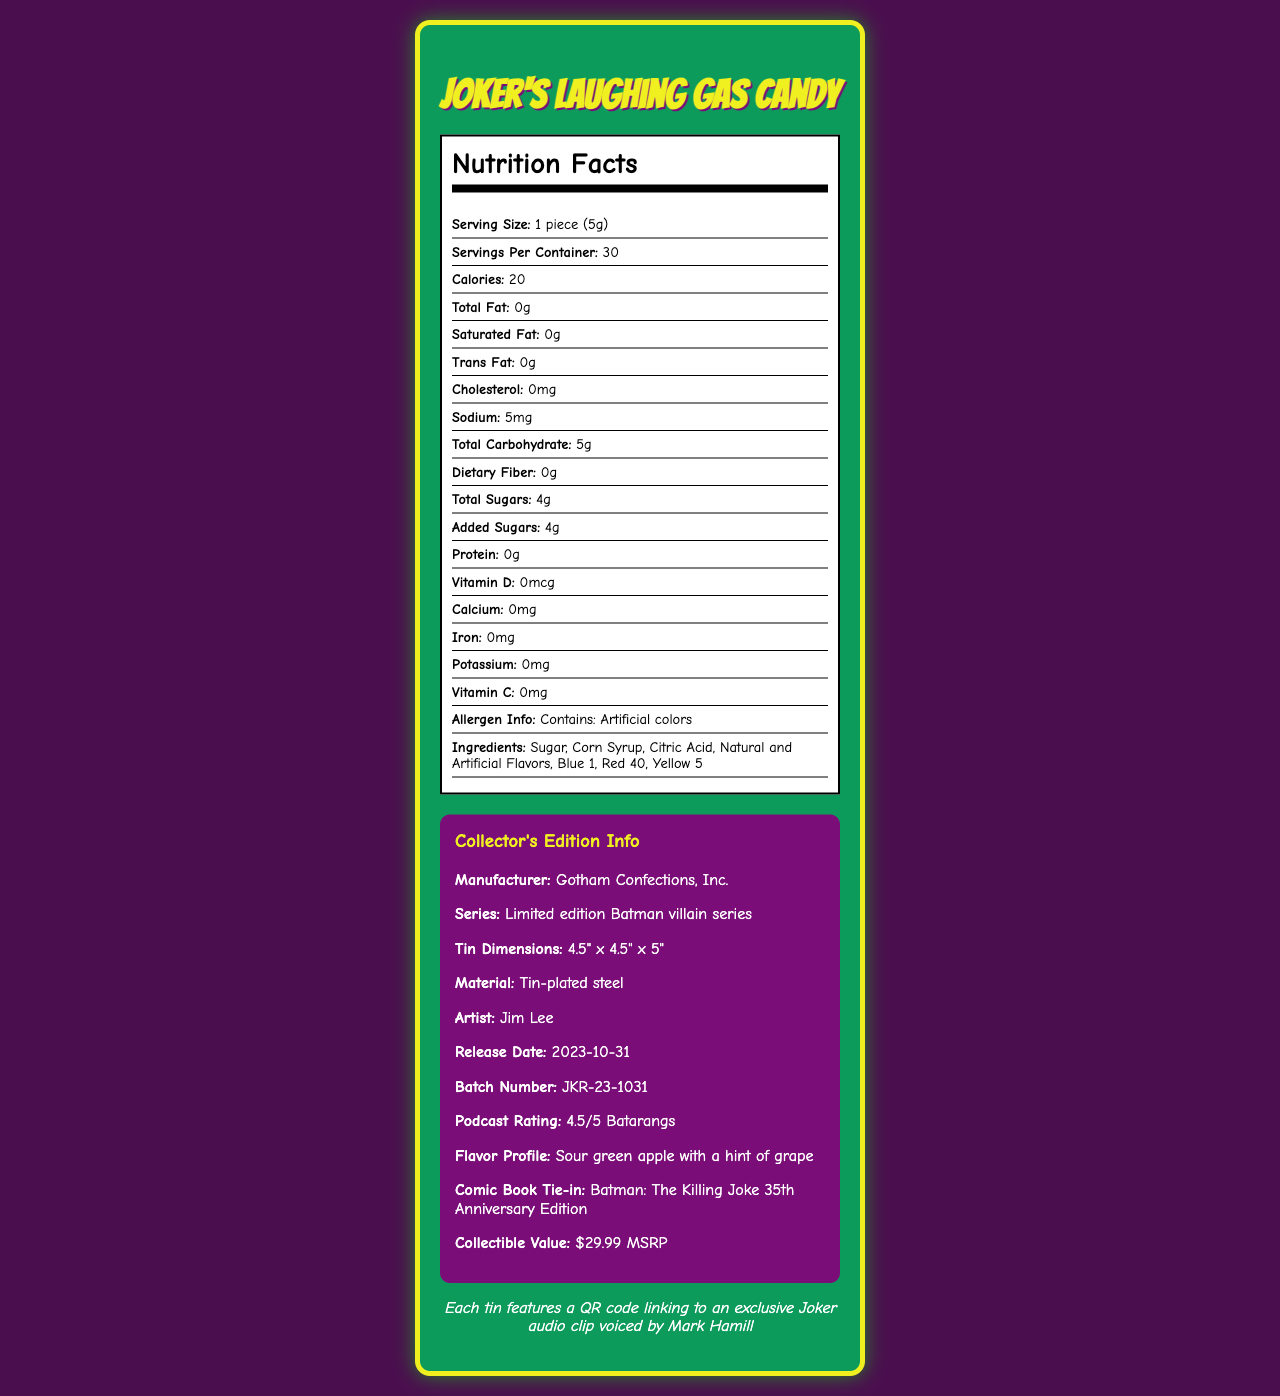what is the serving size? The serving size is explicitly mentioned as "1 piece (5g)" in the nutrition label.
Answer: 1 piece (5g) how many servings are in each container? The document states, "Servings Per Container: 30".
Answer: 30 how many calories are in one serving? The nutrition label shows that one serving contains 20 calories.
Answer: 20 what is the total carbohydrate content per serving? The label lists "Total Carbohydrate: 5g" per serving.
Answer: 5g what is the flavor profile of the candy? The flavor profile is given as "Sour green apple with a hint of grape".
Answer: Sour green apple with a hint of grape which of the following vitamins are present in the candy? A. Vitamin A B. Vitamin B C. Vitamin C D. Vitamin D The nutrition label lists Vitamin C with a value of 0mg, none of the other vitamins are listed.
Answer: C. Vitamin C who is the artist behind the collectible tin design? A. Alex Ross B. Frank Miller C. Jim Lee D. Neal Adams The document states that the artist is Jim Lee.
Answer: C. Jim Lee is any protein present in the candy? The nutrition label mentions "Protein: 0g", meaning there is no protein in the candy.
Answer: No is there any trans fat in the candy? The nutrition label shows "Trans Fat: 0g", indicating there is no trans fat.
Answer: No summarize the main idea of the document. The document includes comprehensive details like nutrition facts, collector's edition specifications, and other interesting information about "Joker's Laughing Gas Candy".
Answer: The document provides detailed nutrition information and collectible details about "Joker's Laughing Gas Candy". It lists the nutritional content, serving size, and ingredients, mentions the product's collector's edition features, and provides additional fun facts and tie-ins with comic book lore. what is the release date of the candy? The collector info section lists the release date as "2023-10-31".
Answer: 2023-10-31 how many grams of added sugars are in each serving? The nutrition label states "Added Sugars: 4g" per serving.
Answer: 4g what is the price of the collectible tin? The document mentions the "Collectible Value: $29.99 MSRP".
Answer: $29.99 which comic book is tied to this collectible tin? The document specifies that the collectible tin ties into "Batman: The Killing Joke 35th Anniversary Edition".
Answer: Batman: The Killing Joke 35th Anniversary Edition does the candy contain any artificial colors? The document lists "Contains: Artificial colors" under allergen info.
Answer: Yes who is the manufacturer of the candy? The document specifies that the manufacturer is "Gotham Confections, Inc."
Answer: Gotham Confections, Inc. what is the main allergen information provided? The allergen info section clearly states "Contains: Artificial colors".
Answer: Contains: Artificial colors how much sodium is present in each serving? The label indicates "Sodium: 5mg" per serving.
Answer: 5mg what are the dimensions of the tin? The collector info section lists the tin dimensions as "4.5" x 4.5" x 5"".
Answer: 4.5" x 4.5" x 5" does the document include contact information for customer support? The document does not provide any contact information for customer support; it focuses on the nutrition facts and collector's information.
Answer: Not enough information 